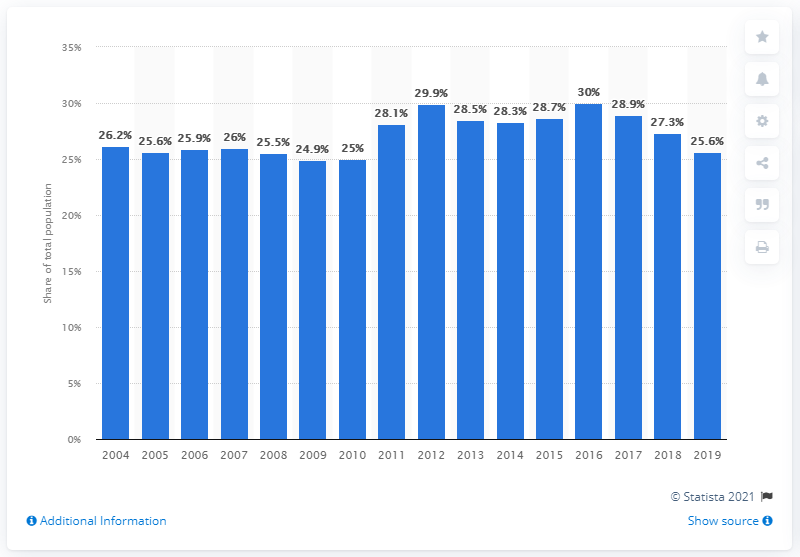Outline some significant characteristics in this image. In 2019, an estimated 25.6% of the Italian population was affected by poverty or social exclusion. 